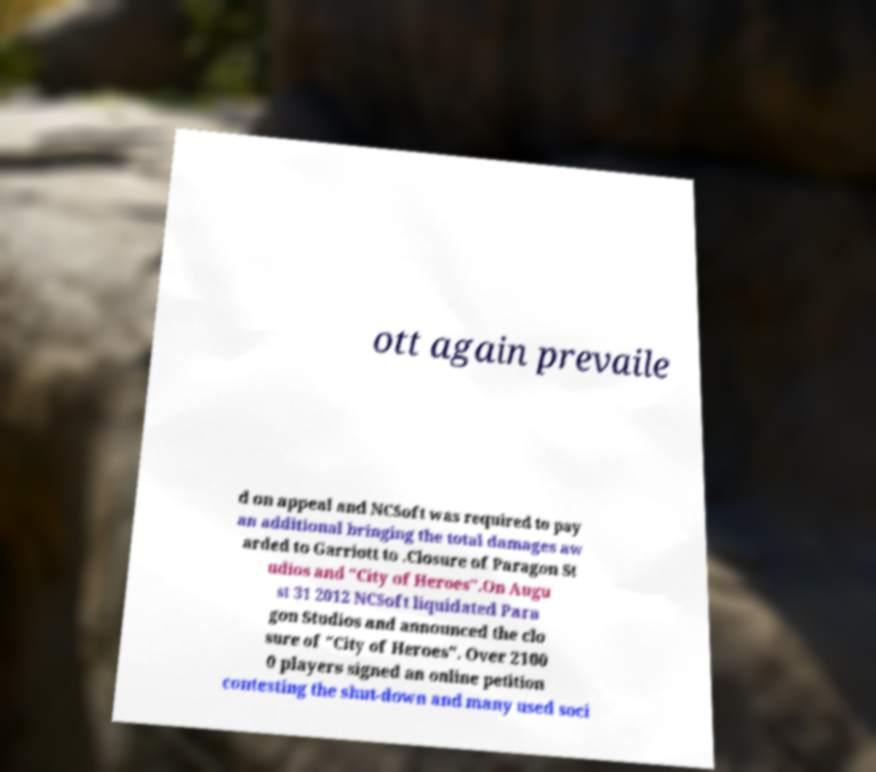I need the written content from this picture converted into text. Can you do that? ott again prevaile d on appeal and NCSoft was required to pay an additional bringing the total damages aw arded to Garriott to .Closure of Paragon St udios and "City of Heroes".On Augu st 31 2012 NCSoft liquidated Para gon Studios and announced the clo sure of "City of Heroes". Over 2100 0 players signed an online petition contesting the shut-down and many used soci 